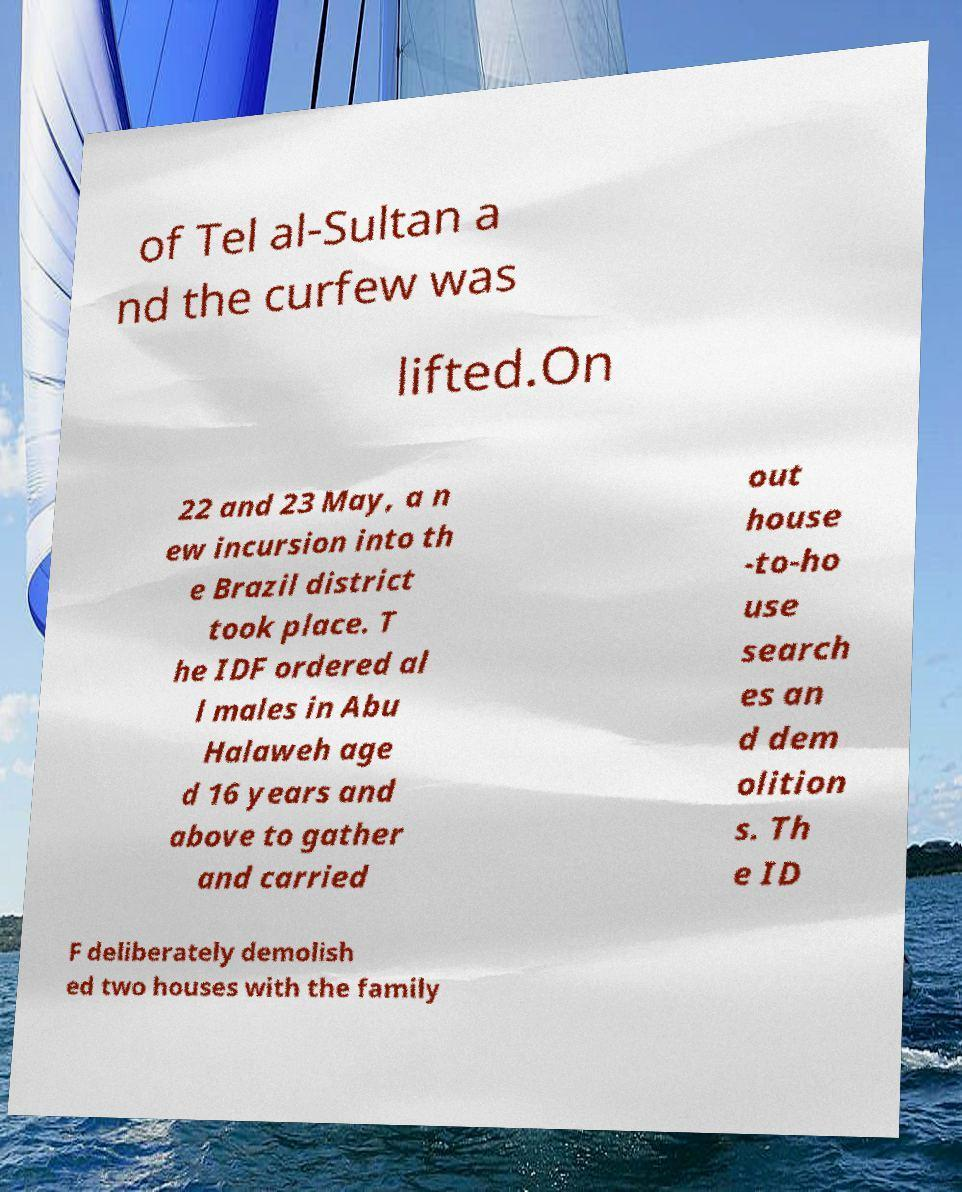Can you accurately transcribe the text from the provided image for me? of Tel al-Sultan a nd the curfew was lifted.On 22 and 23 May, a n ew incursion into th e Brazil district took place. T he IDF ordered al l males in Abu Halaweh age d 16 years and above to gather and carried out house -to-ho use search es an d dem olition s. Th e ID F deliberately demolish ed two houses with the family 